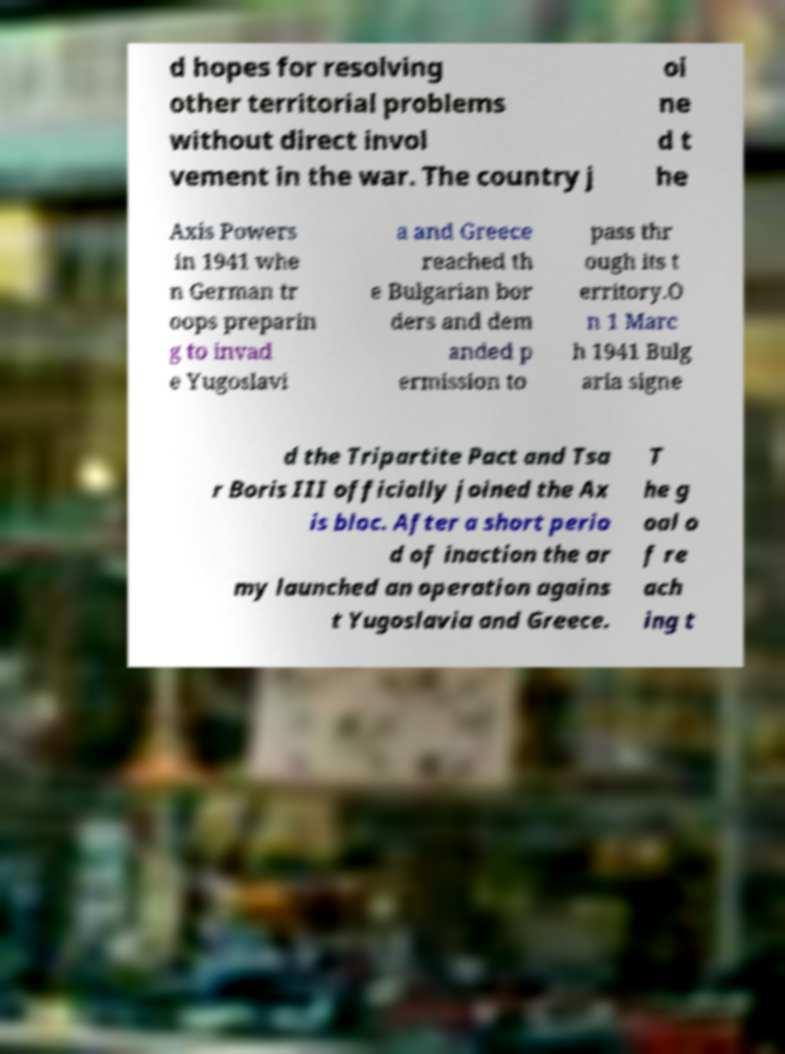Could you assist in decoding the text presented in this image and type it out clearly? d hopes for resolving other territorial problems without direct invol vement in the war. The country j oi ne d t he Axis Powers in 1941 whe n German tr oops preparin g to invad e Yugoslavi a and Greece reached th e Bulgarian bor ders and dem anded p ermission to pass thr ough its t erritory.O n 1 Marc h 1941 Bulg aria signe d the Tripartite Pact and Tsa r Boris III officially joined the Ax is bloc. After a short perio d of inaction the ar my launched an operation agains t Yugoslavia and Greece. T he g oal o f re ach ing t 